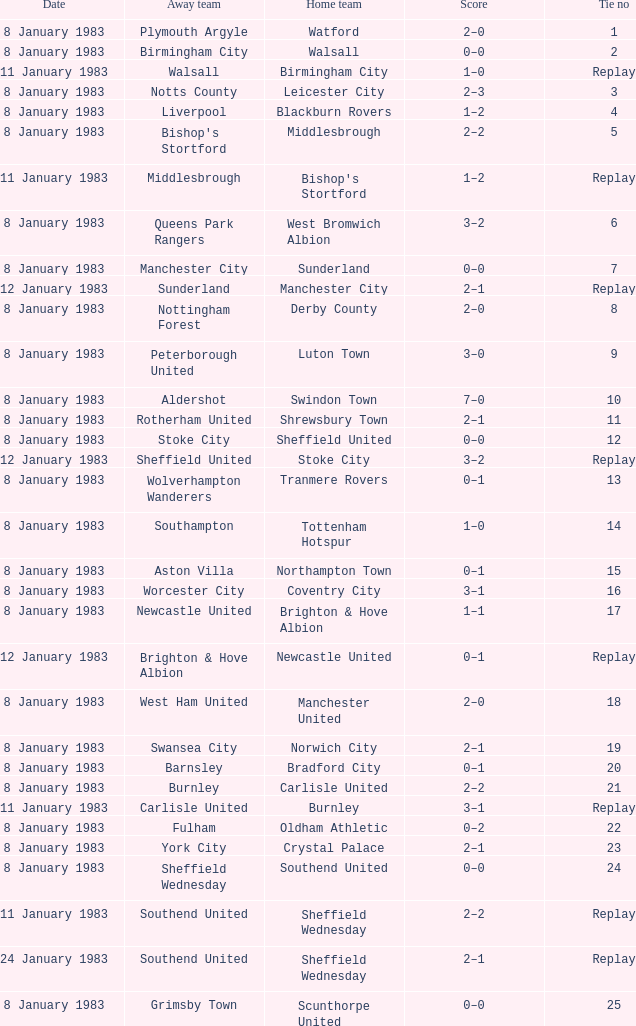What was the final score for the tie where Leeds United was the home team? 3–0. 